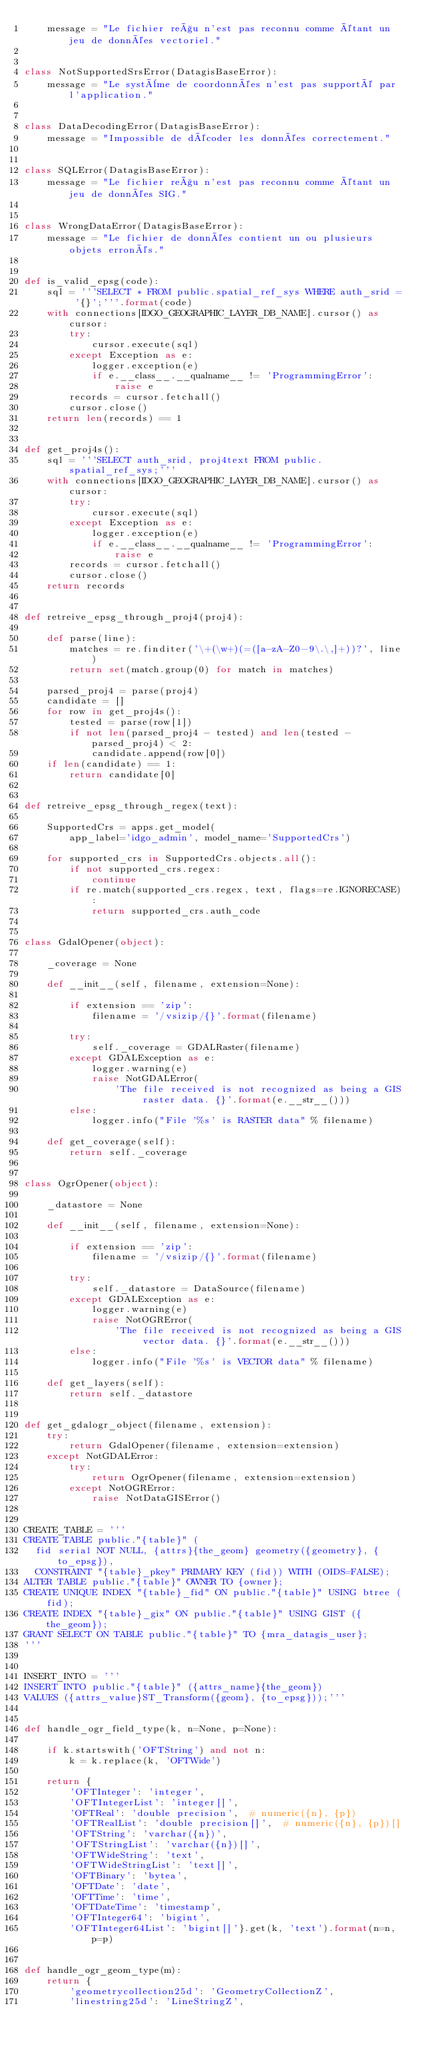Convert code to text. <code><loc_0><loc_0><loc_500><loc_500><_Python_>    message = "Le fichier reçu n'est pas reconnu comme étant un jeu de données vectoriel."


class NotSupportedSrsError(DatagisBaseError):
    message = "Le système de coordonnées n'est pas supporté par l'application."


class DataDecodingError(DatagisBaseError):
    message = "Impossible de décoder les données correctement."


class SQLError(DatagisBaseError):
    message = "Le fichier reçu n'est pas reconnu comme étant un jeu de données SIG."


class WrongDataError(DatagisBaseError):
    message = "Le fichier de données contient un ou plusieurs objets erronés."


def is_valid_epsg(code):
    sql = '''SELECT * FROM public.spatial_ref_sys WHERE auth_srid = '{}';'''.format(code)
    with connections[IDGO_GEOGRAPHIC_LAYER_DB_NAME].cursor() as cursor:
        try:
            cursor.execute(sql)
        except Exception as e:
            logger.exception(e)
            if e.__class__.__qualname__ != 'ProgrammingError':
                raise e
        records = cursor.fetchall()
        cursor.close()
    return len(records) == 1


def get_proj4s():
    sql = '''SELECT auth_srid, proj4text FROM public.spatial_ref_sys;'''
    with connections[IDGO_GEOGRAPHIC_LAYER_DB_NAME].cursor() as cursor:
        try:
            cursor.execute(sql)
        except Exception as e:
            logger.exception(e)
            if e.__class__.__qualname__ != 'ProgrammingError':
                raise e
        records = cursor.fetchall()
        cursor.close()
    return records


def retreive_epsg_through_proj4(proj4):

    def parse(line):
        matches = re.finditer('\+(\w+)(=([a-zA-Z0-9\.\,]+))?', line)
        return set(match.group(0) for match in matches)

    parsed_proj4 = parse(proj4)
    candidate = []
    for row in get_proj4s():
        tested = parse(row[1])
        if not len(parsed_proj4 - tested) and len(tested - parsed_proj4) < 2:
            candidate.append(row[0])
    if len(candidate) == 1:
        return candidate[0]


def retreive_epsg_through_regex(text):

    SupportedCrs = apps.get_model(
        app_label='idgo_admin', model_name='SupportedCrs')

    for supported_crs in SupportedCrs.objects.all():
        if not supported_crs.regex:
            continue
        if re.match(supported_crs.regex, text, flags=re.IGNORECASE):
            return supported_crs.auth_code


class GdalOpener(object):

    _coverage = None

    def __init__(self, filename, extension=None):

        if extension == 'zip':
            filename = '/vsizip/{}'.format(filename)

        try:
            self._coverage = GDALRaster(filename)
        except GDALException as e:
            logger.warning(e)
            raise NotGDALError(
                'The file received is not recognized as being a GIS raster data. {}'.format(e.__str__()))
        else:
            logger.info("File '%s' is RASTER data" % filename)

    def get_coverage(self):
        return self._coverage


class OgrOpener(object):

    _datastore = None

    def __init__(self, filename, extension=None):

        if extension == 'zip':
            filename = '/vsizip/{}'.format(filename)

        try:
            self._datastore = DataSource(filename)
        except GDALException as e:
            logger.warning(e)
            raise NotOGRError(
                'The file received is not recognized as being a GIS vector data. {}'.format(e.__str__()))
        else:
            logger.info("File '%s' is VECTOR data" % filename)

    def get_layers(self):
        return self._datastore


def get_gdalogr_object(filename, extension):
    try:
        return GdalOpener(filename, extension=extension)
    except NotGDALError:
        try:
            return OgrOpener(filename, extension=extension)
        except NotOGRError:
            raise NotDataGISError()


CREATE_TABLE = '''
CREATE TABLE public."{table}" (
  fid serial NOT NULL, {attrs}{the_geom} geometry({geometry}, {to_epsg}),
  CONSTRAINT "{table}_pkey" PRIMARY KEY (fid)) WITH (OIDS=FALSE);
ALTER TABLE public."{table}" OWNER TO {owner};
CREATE UNIQUE INDEX "{table}_fid" ON public."{table}" USING btree (fid);
CREATE INDEX "{table}_gix" ON public."{table}" USING GIST ({the_geom});
GRANT SELECT ON TABLE public."{table}" TO {mra_datagis_user};
'''


INSERT_INTO = '''
INSERT INTO public."{table}" ({attrs_name}{the_geom})
VALUES ({attrs_value}ST_Transform({geom}, {to_epsg}));'''


def handle_ogr_field_type(k, n=None, p=None):

    if k.startswith('OFTString') and not n:
        k = k.replace(k, 'OFTWide')

    return {
        'OFTInteger': 'integer',
        'OFTIntegerList': 'integer[]',
        'OFTReal': 'double precision',  # numeric({n}, {p})
        'OFTRealList': 'double precision[]',  # numeric({n}, {p})[]
        'OFTString': 'varchar({n})',
        'OFTStringList': 'varchar({n})[]',
        'OFTWideString': 'text',
        'OFTWideStringList': 'text[]',
        'OFTBinary': 'bytea',
        'OFTDate': 'date',
        'OFTTime': 'time',
        'OFTDateTime': 'timestamp',
        'OFTInteger64': 'bigint',
        'OFTInteger64List': 'bigint[]'}.get(k, 'text').format(n=n, p=p)


def handle_ogr_geom_type(m):
    return {
        'geometrycollection25d': 'GeometryCollectionZ',
        'linestring25d': 'LineStringZ',</code> 